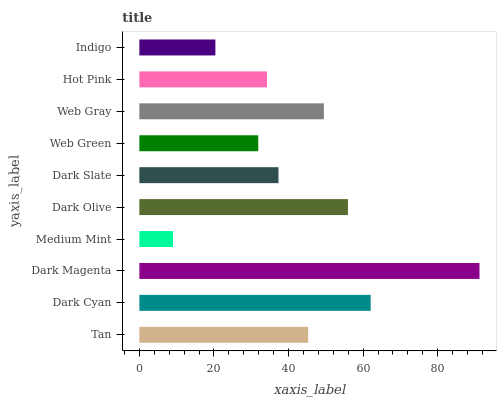Is Medium Mint the minimum?
Answer yes or no. Yes. Is Dark Magenta the maximum?
Answer yes or no. Yes. Is Dark Cyan the minimum?
Answer yes or no. No. Is Dark Cyan the maximum?
Answer yes or no. No. Is Dark Cyan greater than Tan?
Answer yes or no. Yes. Is Tan less than Dark Cyan?
Answer yes or no. Yes. Is Tan greater than Dark Cyan?
Answer yes or no. No. Is Dark Cyan less than Tan?
Answer yes or no. No. Is Tan the high median?
Answer yes or no. Yes. Is Dark Slate the low median?
Answer yes or no. Yes. Is Dark Magenta the high median?
Answer yes or no. No. Is Tan the low median?
Answer yes or no. No. 